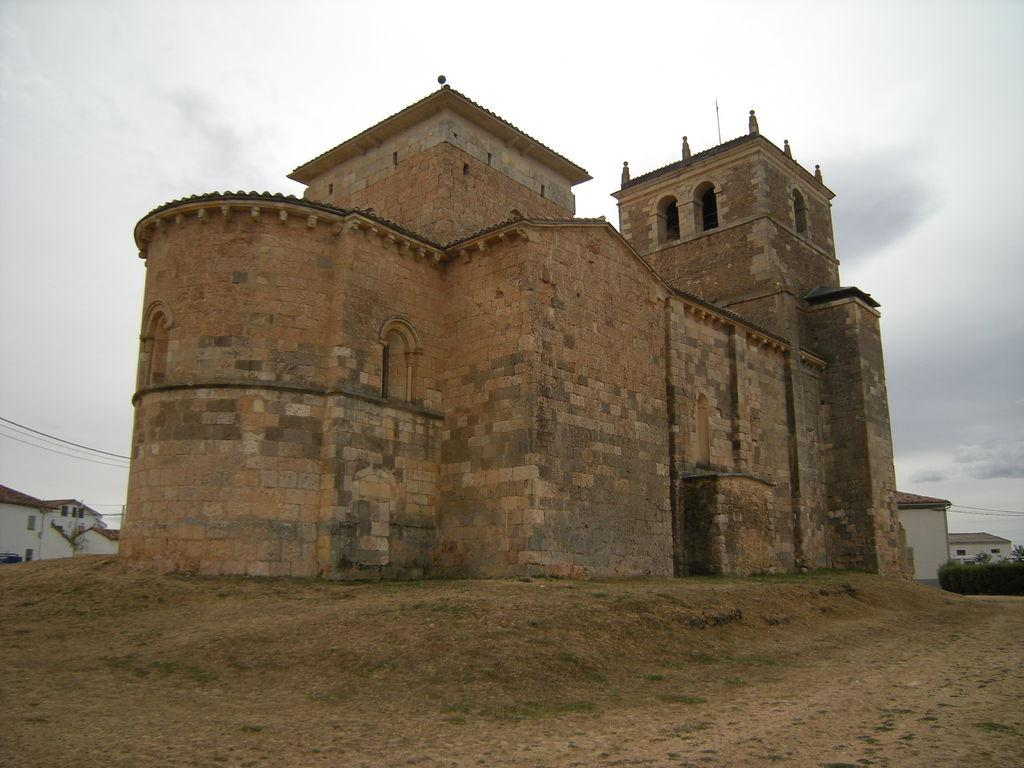What is the main structure in the image? There is a building in the image. What type of vegetation is present near the building? There are plants beside the building. What can be seen in the distance in the image? There is a sky visible in the background of the image. How many times does the person in the image sneeze? There is no person present in the image, so it is not possible to determine how many times they sneeze. 